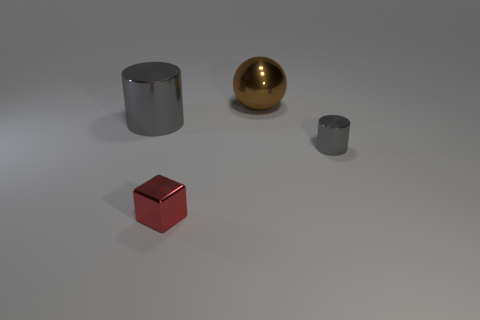Can you describe the lighting and shadows visible in the scene? The scene is lit from above, casting soft shadows beneath each object. The shadows are slightly diffused, suggesting the light source is not overly intense. The angle of the light is such that the shadows extend mostly to the left and slightly forward from the position of the objects. 